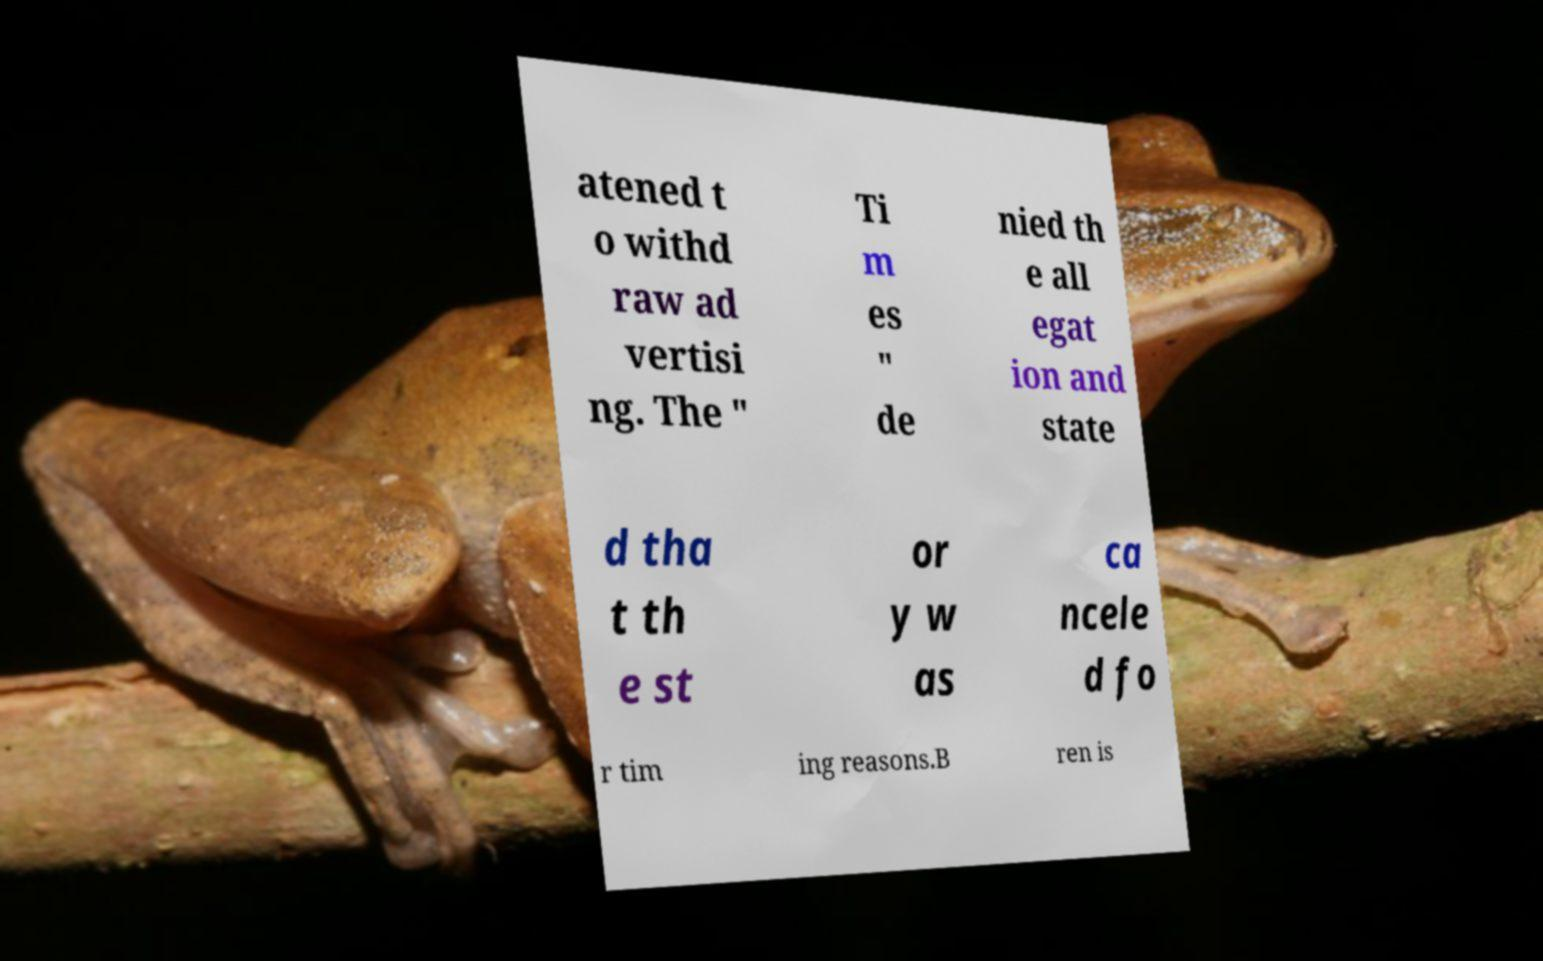For documentation purposes, I need the text within this image transcribed. Could you provide that? atened t o withd raw ad vertisi ng. The " Ti m es " de nied th e all egat ion and state d tha t th e st or y w as ca ncele d fo r tim ing reasons.B ren is 